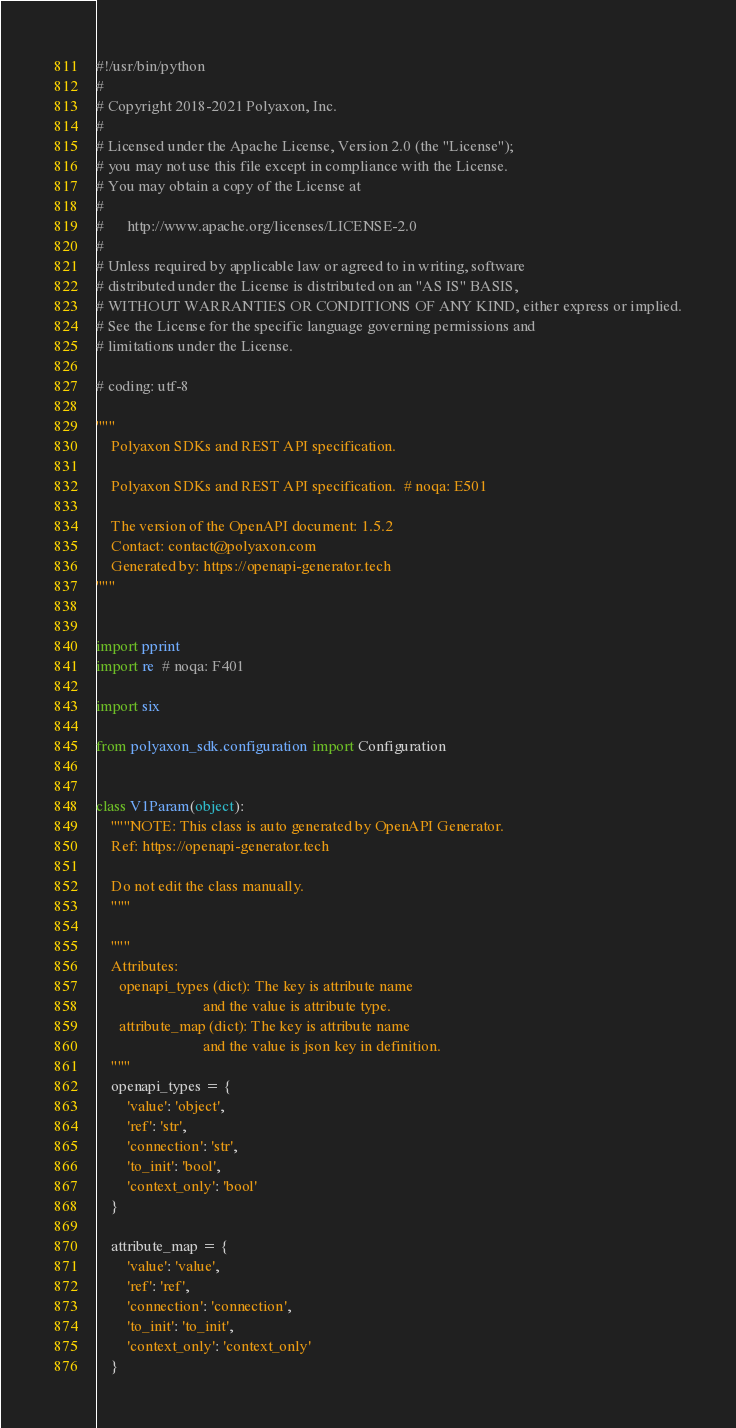<code> <loc_0><loc_0><loc_500><loc_500><_Python_>#!/usr/bin/python
#
# Copyright 2018-2021 Polyaxon, Inc.
#
# Licensed under the Apache License, Version 2.0 (the "License");
# you may not use this file except in compliance with the License.
# You may obtain a copy of the License at
#
#      http://www.apache.org/licenses/LICENSE-2.0
#
# Unless required by applicable law or agreed to in writing, software
# distributed under the License is distributed on an "AS IS" BASIS,
# WITHOUT WARRANTIES OR CONDITIONS OF ANY KIND, either express or implied.
# See the License for the specific language governing permissions and
# limitations under the License.

# coding: utf-8

"""
    Polyaxon SDKs and REST API specification.

    Polyaxon SDKs and REST API specification.  # noqa: E501

    The version of the OpenAPI document: 1.5.2
    Contact: contact@polyaxon.com
    Generated by: https://openapi-generator.tech
"""


import pprint
import re  # noqa: F401

import six

from polyaxon_sdk.configuration import Configuration


class V1Param(object):
    """NOTE: This class is auto generated by OpenAPI Generator.
    Ref: https://openapi-generator.tech

    Do not edit the class manually.
    """

    """
    Attributes:
      openapi_types (dict): The key is attribute name
                            and the value is attribute type.
      attribute_map (dict): The key is attribute name
                            and the value is json key in definition.
    """
    openapi_types = {
        'value': 'object',
        'ref': 'str',
        'connection': 'str',
        'to_init': 'bool',
        'context_only': 'bool'
    }

    attribute_map = {
        'value': 'value',
        'ref': 'ref',
        'connection': 'connection',
        'to_init': 'to_init',
        'context_only': 'context_only'
    }
</code> 